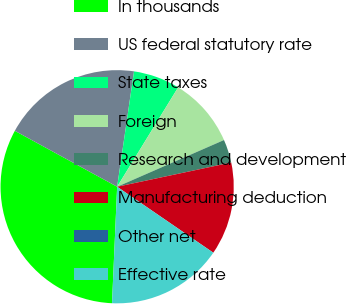<chart> <loc_0><loc_0><loc_500><loc_500><pie_chart><fcel>In thousands<fcel>US federal statutory rate<fcel>State taxes<fcel>Foreign<fcel>Research and development<fcel>Manufacturing deduction<fcel>Other net<fcel>Effective rate<nl><fcel>32.26%<fcel>19.35%<fcel>6.45%<fcel>9.68%<fcel>3.23%<fcel>12.9%<fcel>0.0%<fcel>16.13%<nl></chart> 